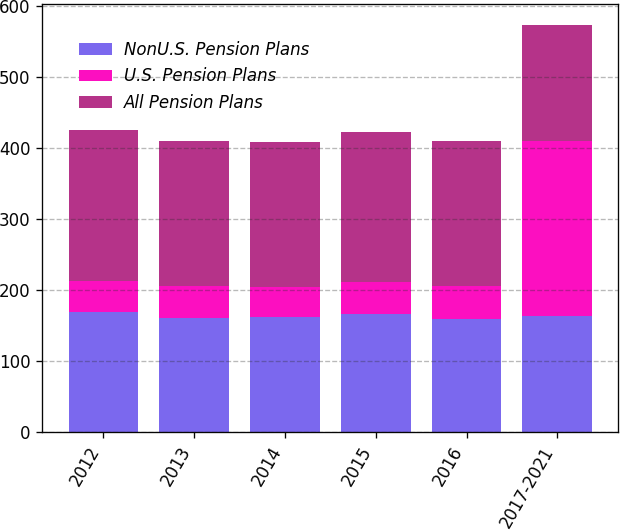Convert chart to OTSL. <chart><loc_0><loc_0><loc_500><loc_500><stacked_bar_chart><ecel><fcel>2012<fcel>2013<fcel>2014<fcel>2015<fcel>2016<fcel>2017-2021<nl><fcel>NonU.S. Pension Plans<fcel>168.9<fcel>161.1<fcel>161.6<fcel>165.9<fcel>159<fcel>163.75<nl><fcel>U.S. Pension Plans<fcel>44.3<fcel>44.1<fcel>42.7<fcel>45.3<fcel>46.3<fcel>246.7<nl><fcel>All Pension Plans<fcel>213.2<fcel>205.2<fcel>204.3<fcel>211.2<fcel>205.3<fcel>163.75<nl></chart> 